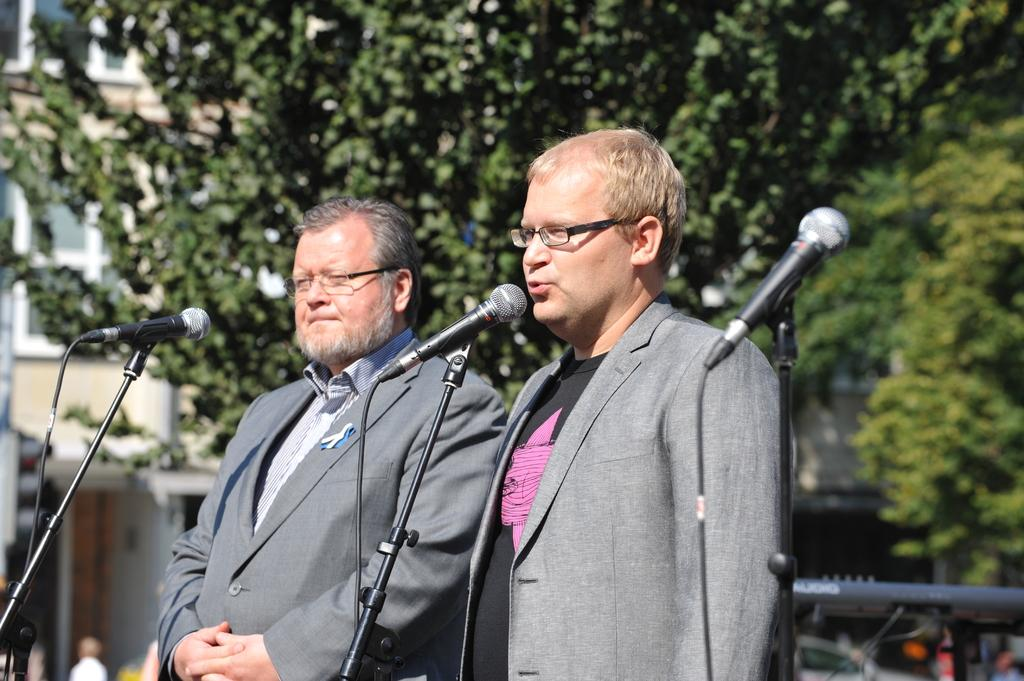How many people are in the image? There are two men in the image. What are the men wearing? The men are wearing suits and spectacles. What are the men doing in the image? The men are standing behind microphones. What can be seen in the background of the image? There are trees and buildings in the background of the image. What type of debt is being discussed by the men in the image? There is no indication in the image that the men are discussing any type of debt. What operation is being performed by the men in the image? There is no operation being performed by the men in the image; they are simply standing behind microphones. 